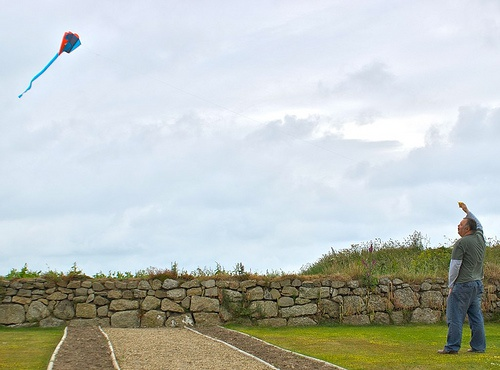Describe the objects in this image and their specific colors. I can see people in lavender, gray, blue, black, and darkblue tones and kite in lavender, lightblue, blue, gray, and teal tones in this image. 